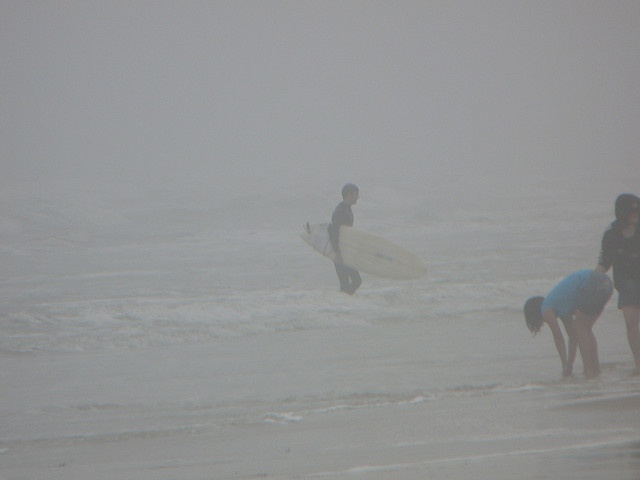Describe the objects in this image and their specific colors. I can see people in gray tones, surfboard in gray and darkgray tones, people in gray tones, and people in gray tones in this image. 